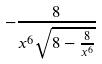Convert formula to latex. <formula><loc_0><loc_0><loc_500><loc_500>- \frac { 8 } { x ^ { 6 } \sqrt { 8 - \frac { 8 } { x ^ { 6 } } } }</formula> 